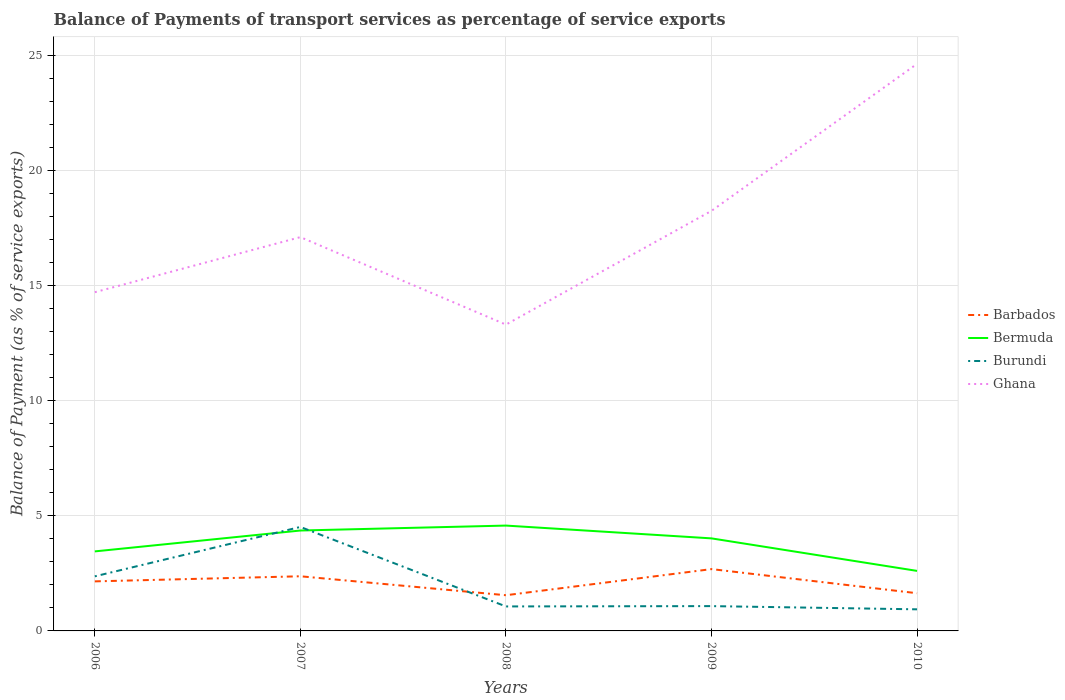Is the number of lines equal to the number of legend labels?
Your answer should be compact. Yes. Across all years, what is the maximum balance of payments of transport services in Ghana?
Provide a succinct answer. 13.3. In which year was the balance of payments of transport services in Bermuda maximum?
Offer a terse response. 2010. What is the total balance of payments of transport services in Burundi in the graph?
Your response must be concise. 0.14. What is the difference between the highest and the second highest balance of payments of transport services in Barbados?
Ensure brevity in your answer.  1.13. What is the difference between the highest and the lowest balance of payments of transport services in Barbados?
Give a very brief answer. 3. How many lines are there?
Offer a very short reply. 4. What is the difference between two consecutive major ticks on the Y-axis?
Your answer should be compact. 5. Are the values on the major ticks of Y-axis written in scientific E-notation?
Give a very brief answer. No. Does the graph contain any zero values?
Provide a succinct answer. No. Does the graph contain grids?
Provide a succinct answer. Yes. Where does the legend appear in the graph?
Offer a terse response. Center right. How many legend labels are there?
Offer a very short reply. 4. How are the legend labels stacked?
Ensure brevity in your answer.  Vertical. What is the title of the graph?
Your response must be concise. Balance of Payments of transport services as percentage of service exports. Does "Belgium" appear as one of the legend labels in the graph?
Give a very brief answer. No. What is the label or title of the X-axis?
Ensure brevity in your answer.  Years. What is the label or title of the Y-axis?
Provide a succinct answer. Balance of Payment (as % of service exports). What is the Balance of Payment (as % of service exports) of Barbados in 2006?
Your answer should be compact. 2.15. What is the Balance of Payment (as % of service exports) of Bermuda in 2006?
Give a very brief answer. 3.45. What is the Balance of Payment (as % of service exports) in Burundi in 2006?
Your answer should be very brief. 2.37. What is the Balance of Payment (as % of service exports) in Ghana in 2006?
Ensure brevity in your answer.  14.71. What is the Balance of Payment (as % of service exports) in Barbados in 2007?
Your response must be concise. 2.37. What is the Balance of Payment (as % of service exports) of Bermuda in 2007?
Provide a short and direct response. 4.36. What is the Balance of Payment (as % of service exports) of Burundi in 2007?
Give a very brief answer. 4.51. What is the Balance of Payment (as % of service exports) in Ghana in 2007?
Ensure brevity in your answer.  17.1. What is the Balance of Payment (as % of service exports) in Barbados in 2008?
Offer a very short reply. 1.55. What is the Balance of Payment (as % of service exports) in Bermuda in 2008?
Keep it short and to the point. 4.57. What is the Balance of Payment (as % of service exports) in Burundi in 2008?
Provide a succinct answer. 1.06. What is the Balance of Payment (as % of service exports) in Ghana in 2008?
Keep it short and to the point. 13.3. What is the Balance of Payment (as % of service exports) of Barbados in 2009?
Provide a short and direct response. 2.68. What is the Balance of Payment (as % of service exports) in Bermuda in 2009?
Your answer should be very brief. 4.02. What is the Balance of Payment (as % of service exports) in Burundi in 2009?
Ensure brevity in your answer.  1.08. What is the Balance of Payment (as % of service exports) in Ghana in 2009?
Ensure brevity in your answer.  18.24. What is the Balance of Payment (as % of service exports) in Barbados in 2010?
Your answer should be very brief. 1.64. What is the Balance of Payment (as % of service exports) of Bermuda in 2010?
Provide a succinct answer. 2.61. What is the Balance of Payment (as % of service exports) in Burundi in 2010?
Your response must be concise. 0.94. What is the Balance of Payment (as % of service exports) of Ghana in 2010?
Offer a very short reply. 24.62. Across all years, what is the maximum Balance of Payment (as % of service exports) in Barbados?
Your answer should be compact. 2.68. Across all years, what is the maximum Balance of Payment (as % of service exports) of Bermuda?
Make the answer very short. 4.57. Across all years, what is the maximum Balance of Payment (as % of service exports) of Burundi?
Provide a succinct answer. 4.51. Across all years, what is the maximum Balance of Payment (as % of service exports) of Ghana?
Give a very brief answer. 24.62. Across all years, what is the minimum Balance of Payment (as % of service exports) of Barbados?
Offer a terse response. 1.55. Across all years, what is the minimum Balance of Payment (as % of service exports) in Bermuda?
Provide a short and direct response. 2.61. Across all years, what is the minimum Balance of Payment (as % of service exports) of Burundi?
Your answer should be very brief. 0.94. Across all years, what is the minimum Balance of Payment (as % of service exports) of Ghana?
Make the answer very short. 13.3. What is the total Balance of Payment (as % of service exports) of Barbados in the graph?
Give a very brief answer. 10.4. What is the total Balance of Payment (as % of service exports) in Bermuda in the graph?
Offer a terse response. 19.01. What is the total Balance of Payment (as % of service exports) of Burundi in the graph?
Keep it short and to the point. 9.96. What is the total Balance of Payment (as % of service exports) of Ghana in the graph?
Offer a very short reply. 87.97. What is the difference between the Balance of Payment (as % of service exports) in Barbados in 2006 and that in 2007?
Ensure brevity in your answer.  -0.22. What is the difference between the Balance of Payment (as % of service exports) in Bermuda in 2006 and that in 2007?
Provide a succinct answer. -0.91. What is the difference between the Balance of Payment (as % of service exports) in Burundi in 2006 and that in 2007?
Offer a very short reply. -2.14. What is the difference between the Balance of Payment (as % of service exports) in Ghana in 2006 and that in 2007?
Provide a succinct answer. -2.39. What is the difference between the Balance of Payment (as % of service exports) in Barbados in 2006 and that in 2008?
Provide a succinct answer. 0.6. What is the difference between the Balance of Payment (as % of service exports) of Bermuda in 2006 and that in 2008?
Offer a very short reply. -1.12. What is the difference between the Balance of Payment (as % of service exports) in Burundi in 2006 and that in 2008?
Give a very brief answer. 1.31. What is the difference between the Balance of Payment (as % of service exports) in Ghana in 2006 and that in 2008?
Offer a very short reply. 1.41. What is the difference between the Balance of Payment (as % of service exports) in Barbados in 2006 and that in 2009?
Keep it short and to the point. -0.53. What is the difference between the Balance of Payment (as % of service exports) of Bermuda in 2006 and that in 2009?
Provide a short and direct response. -0.57. What is the difference between the Balance of Payment (as % of service exports) of Burundi in 2006 and that in 2009?
Give a very brief answer. 1.29. What is the difference between the Balance of Payment (as % of service exports) of Ghana in 2006 and that in 2009?
Keep it short and to the point. -3.53. What is the difference between the Balance of Payment (as % of service exports) of Barbados in 2006 and that in 2010?
Provide a succinct answer. 0.51. What is the difference between the Balance of Payment (as % of service exports) in Bermuda in 2006 and that in 2010?
Your response must be concise. 0.85. What is the difference between the Balance of Payment (as % of service exports) in Burundi in 2006 and that in 2010?
Ensure brevity in your answer.  1.43. What is the difference between the Balance of Payment (as % of service exports) of Ghana in 2006 and that in 2010?
Provide a short and direct response. -9.91. What is the difference between the Balance of Payment (as % of service exports) in Barbados in 2007 and that in 2008?
Ensure brevity in your answer.  0.82. What is the difference between the Balance of Payment (as % of service exports) in Bermuda in 2007 and that in 2008?
Your answer should be very brief. -0.21. What is the difference between the Balance of Payment (as % of service exports) in Burundi in 2007 and that in 2008?
Offer a terse response. 3.45. What is the difference between the Balance of Payment (as % of service exports) in Ghana in 2007 and that in 2008?
Offer a very short reply. 3.8. What is the difference between the Balance of Payment (as % of service exports) in Barbados in 2007 and that in 2009?
Ensure brevity in your answer.  -0.31. What is the difference between the Balance of Payment (as % of service exports) in Bermuda in 2007 and that in 2009?
Keep it short and to the point. 0.34. What is the difference between the Balance of Payment (as % of service exports) of Burundi in 2007 and that in 2009?
Provide a succinct answer. 3.44. What is the difference between the Balance of Payment (as % of service exports) of Ghana in 2007 and that in 2009?
Your answer should be very brief. -1.14. What is the difference between the Balance of Payment (as % of service exports) of Barbados in 2007 and that in 2010?
Provide a short and direct response. 0.74. What is the difference between the Balance of Payment (as % of service exports) of Bermuda in 2007 and that in 2010?
Offer a very short reply. 1.75. What is the difference between the Balance of Payment (as % of service exports) of Burundi in 2007 and that in 2010?
Your answer should be compact. 3.58. What is the difference between the Balance of Payment (as % of service exports) in Ghana in 2007 and that in 2010?
Your response must be concise. -7.52. What is the difference between the Balance of Payment (as % of service exports) in Barbados in 2008 and that in 2009?
Give a very brief answer. -1.13. What is the difference between the Balance of Payment (as % of service exports) of Bermuda in 2008 and that in 2009?
Your answer should be compact. 0.56. What is the difference between the Balance of Payment (as % of service exports) of Burundi in 2008 and that in 2009?
Your response must be concise. -0.01. What is the difference between the Balance of Payment (as % of service exports) of Ghana in 2008 and that in 2009?
Your answer should be compact. -4.94. What is the difference between the Balance of Payment (as % of service exports) of Barbados in 2008 and that in 2010?
Provide a short and direct response. -0.09. What is the difference between the Balance of Payment (as % of service exports) of Bermuda in 2008 and that in 2010?
Provide a short and direct response. 1.97. What is the difference between the Balance of Payment (as % of service exports) of Burundi in 2008 and that in 2010?
Provide a short and direct response. 0.13. What is the difference between the Balance of Payment (as % of service exports) in Ghana in 2008 and that in 2010?
Provide a succinct answer. -11.32. What is the difference between the Balance of Payment (as % of service exports) in Barbados in 2009 and that in 2010?
Your response must be concise. 1.05. What is the difference between the Balance of Payment (as % of service exports) of Bermuda in 2009 and that in 2010?
Your answer should be compact. 1.41. What is the difference between the Balance of Payment (as % of service exports) of Burundi in 2009 and that in 2010?
Keep it short and to the point. 0.14. What is the difference between the Balance of Payment (as % of service exports) in Ghana in 2009 and that in 2010?
Make the answer very short. -6.38. What is the difference between the Balance of Payment (as % of service exports) of Barbados in 2006 and the Balance of Payment (as % of service exports) of Bermuda in 2007?
Provide a succinct answer. -2.21. What is the difference between the Balance of Payment (as % of service exports) in Barbados in 2006 and the Balance of Payment (as % of service exports) in Burundi in 2007?
Ensure brevity in your answer.  -2.36. What is the difference between the Balance of Payment (as % of service exports) of Barbados in 2006 and the Balance of Payment (as % of service exports) of Ghana in 2007?
Your answer should be compact. -14.95. What is the difference between the Balance of Payment (as % of service exports) of Bermuda in 2006 and the Balance of Payment (as % of service exports) of Burundi in 2007?
Ensure brevity in your answer.  -1.06. What is the difference between the Balance of Payment (as % of service exports) in Bermuda in 2006 and the Balance of Payment (as % of service exports) in Ghana in 2007?
Your answer should be compact. -13.65. What is the difference between the Balance of Payment (as % of service exports) in Burundi in 2006 and the Balance of Payment (as % of service exports) in Ghana in 2007?
Offer a very short reply. -14.73. What is the difference between the Balance of Payment (as % of service exports) in Barbados in 2006 and the Balance of Payment (as % of service exports) in Bermuda in 2008?
Keep it short and to the point. -2.42. What is the difference between the Balance of Payment (as % of service exports) of Barbados in 2006 and the Balance of Payment (as % of service exports) of Burundi in 2008?
Offer a very short reply. 1.09. What is the difference between the Balance of Payment (as % of service exports) of Barbados in 2006 and the Balance of Payment (as % of service exports) of Ghana in 2008?
Provide a succinct answer. -11.15. What is the difference between the Balance of Payment (as % of service exports) in Bermuda in 2006 and the Balance of Payment (as % of service exports) in Burundi in 2008?
Ensure brevity in your answer.  2.39. What is the difference between the Balance of Payment (as % of service exports) in Bermuda in 2006 and the Balance of Payment (as % of service exports) in Ghana in 2008?
Your answer should be compact. -9.85. What is the difference between the Balance of Payment (as % of service exports) in Burundi in 2006 and the Balance of Payment (as % of service exports) in Ghana in 2008?
Make the answer very short. -10.93. What is the difference between the Balance of Payment (as % of service exports) in Barbados in 2006 and the Balance of Payment (as % of service exports) in Bermuda in 2009?
Offer a terse response. -1.87. What is the difference between the Balance of Payment (as % of service exports) in Barbados in 2006 and the Balance of Payment (as % of service exports) in Burundi in 2009?
Offer a terse response. 1.07. What is the difference between the Balance of Payment (as % of service exports) of Barbados in 2006 and the Balance of Payment (as % of service exports) of Ghana in 2009?
Your answer should be very brief. -16.09. What is the difference between the Balance of Payment (as % of service exports) of Bermuda in 2006 and the Balance of Payment (as % of service exports) of Burundi in 2009?
Provide a succinct answer. 2.38. What is the difference between the Balance of Payment (as % of service exports) in Bermuda in 2006 and the Balance of Payment (as % of service exports) in Ghana in 2009?
Give a very brief answer. -14.79. What is the difference between the Balance of Payment (as % of service exports) of Burundi in 2006 and the Balance of Payment (as % of service exports) of Ghana in 2009?
Give a very brief answer. -15.87. What is the difference between the Balance of Payment (as % of service exports) in Barbados in 2006 and the Balance of Payment (as % of service exports) in Bermuda in 2010?
Ensure brevity in your answer.  -0.45. What is the difference between the Balance of Payment (as % of service exports) in Barbados in 2006 and the Balance of Payment (as % of service exports) in Burundi in 2010?
Offer a terse response. 1.21. What is the difference between the Balance of Payment (as % of service exports) in Barbados in 2006 and the Balance of Payment (as % of service exports) in Ghana in 2010?
Provide a short and direct response. -22.47. What is the difference between the Balance of Payment (as % of service exports) in Bermuda in 2006 and the Balance of Payment (as % of service exports) in Burundi in 2010?
Provide a short and direct response. 2.52. What is the difference between the Balance of Payment (as % of service exports) of Bermuda in 2006 and the Balance of Payment (as % of service exports) of Ghana in 2010?
Provide a succinct answer. -21.17. What is the difference between the Balance of Payment (as % of service exports) in Burundi in 2006 and the Balance of Payment (as % of service exports) in Ghana in 2010?
Offer a very short reply. -22.25. What is the difference between the Balance of Payment (as % of service exports) of Barbados in 2007 and the Balance of Payment (as % of service exports) of Bermuda in 2008?
Your answer should be very brief. -2.2. What is the difference between the Balance of Payment (as % of service exports) in Barbados in 2007 and the Balance of Payment (as % of service exports) in Burundi in 2008?
Your answer should be very brief. 1.31. What is the difference between the Balance of Payment (as % of service exports) in Barbados in 2007 and the Balance of Payment (as % of service exports) in Ghana in 2008?
Ensure brevity in your answer.  -10.93. What is the difference between the Balance of Payment (as % of service exports) of Bermuda in 2007 and the Balance of Payment (as % of service exports) of Burundi in 2008?
Make the answer very short. 3.3. What is the difference between the Balance of Payment (as % of service exports) in Bermuda in 2007 and the Balance of Payment (as % of service exports) in Ghana in 2008?
Offer a terse response. -8.94. What is the difference between the Balance of Payment (as % of service exports) of Burundi in 2007 and the Balance of Payment (as % of service exports) of Ghana in 2008?
Your answer should be very brief. -8.79. What is the difference between the Balance of Payment (as % of service exports) in Barbados in 2007 and the Balance of Payment (as % of service exports) in Bermuda in 2009?
Provide a succinct answer. -1.65. What is the difference between the Balance of Payment (as % of service exports) of Barbados in 2007 and the Balance of Payment (as % of service exports) of Burundi in 2009?
Your answer should be compact. 1.3. What is the difference between the Balance of Payment (as % of service exports) in Barbados in 2007 and the Balance of Payment (as % of service exports) in Ghana in 2009?
Your response must be concise. -15.87. What is the difference between the Balance of Payment (as % of service exports) of Bermuda in 2007 and the Balance of Payment (as % of service exports) of Burundi in 2009?
Provide a succinct answer. 3.28. What is the difference between the Balance of Payment (as % of service exports) of Bermuda in 2007 and the Balance of Payment (as % of service exports) of Ghana in 2009?
Give a very brief answer. -13.88. What is the difference between the Balance of Payment (as % of service exports) in Burundi in 2007 and the Balance of Payment (as % of service exports) in Ghana in 2009?
Make the answer very short. -13.72. What is the difference between the Balance of Payment (as % of service exports) in Barbados in 2007 and the Balance of Payment (as % of service exports) in Bermuda in 2010?
Provide a short and direct response. -0.23. What is the difference between the Balance of Payment (as % of service exports) in Barbados in 2007 and the Balance of Payment (as % of service exports) in Burundi in 2010?
Your answer should be compact. 1.44. What is the difference between the Balance of Payment (as % of service exports) in Barbados in 2007 and the Balance of Payment (as % of service exports) in Ghana in 2010?
Your answer should be very brief. -22.25. What is the difference between the Balance of Payment (as % of service exports) of Bermuda in 2007 and the Balance of Payment (as % of service exports) of Burundi in 2010?
Your response must be concise. 3.42. What is the difference between the Balance of Payment (as % of service exports) in Bermuda in 2007 and the Balance of Payment (as % of service exports) in Ghana in 2010?
Provide a succinct answer. -20.26. What is the difference between the Balance of Payment (as % of service exports) of Burundi in 2007 and the Balance of Payment (as % of service exports) of Ghana in 2010?
Provide a succinct answer. -20.11. What is the difference between the Balance of Payment (as % of service exports) of Barbados in 2008 and the Balance of Payment (as % of service exports) of Bermuda in 2009?
Provide a short and direct response. -2.47. What is the difference between the Balance of Payment (as % of service exports) in Barbados in 2008 and the Balance of Payment (as % of service exports) in Burundi in 2009?
Provide a short and direct response. 0.47. What is the difference between the Balance of Payment (as % of service exports) in Barbados in 2008 and the Balance of Payment (as % of service exports) in Ghana in 2009?
Your answer should be compact. -16.69. What is the difference between the Balance of Payment (as % of service exports) of Bermuda in 2008 and the Balance of Payment (as % of service exports) of Burundi in 2009?
Your answer should be very brief. 3.5. What is the difference between the Balance of Payment (as % of service exports) of Bermuda in 2008 and the Balance of Payment (as % of service exports) of Ghana in 2009?
Provide a short and direct response. -13.66. What is the difference between the Balance of Payment (as % of service exports) of Burundi in 2008 and the Balance of Payment (as % of service exports) of Ghana in 2009?
Your answer should be compact. -17.18. What is the difference between the Balance of Payment (as % of service exports) in Barbados in 2008 and the Balance of Payment (as % of service exports) in Bermuda in 2010?
Offer a very short reply. -1.06. What is the difference between the Balance of Payment (as % of service exports) in Barbados in 2008 and the Balance of Payment (as % of service exports) in Burundi in 2010?
Ensure brevity in your answer.  0.61. What is the difference between the Balance of Payment (as % of service exports) of Barbados in 2008 and the Balance of Payment (as % of service exports) of Ghana in 2010?
Provide a succinct answer. -23.07. What is the difference between the Balance of Payment (as % of service exports) of Bermuda in 2008 and the Balance of Payment (as % of service exports) of Burundi in 2010?
Provide a succinct answer. 3.64. What is the difference between the Balance of Payment (as % of service exports) in Bermuda in 2008 and the Balance of Payment (as % of service exports) in Ghana in 2010?
Give a very brief answer. -20.05. What is the difference between the Balance of Payment (as % of service exports) in Burundi in 2008 and the Balance of Payment (as % of service exports) in Ghana in 2010?
Offer a terse response. -23.56. What is the difference between the Balance of Payment (as % of service exports) of Barbados in 2009 and the Balance of Payment (as % of service exports) of Bermuda in 2010?
Your answer should be compact. 0.08. What is the difference between the Balance of Payment (as % of service exports) of Barbados in 2009 and the Balance of Payment (as % of service exports) of Burundi in 2010?
Your response must be concise. 1.75. What is the difference between the Balance of Payment (as % of service exports) in Barbados in 2009 and the Balance of Payment (as % of service exports) in Ghana in 2010?
Your response must be concise. -21.94. What is the difference between the Balance of Payment (as % of service exports) in Bermuda in 2009 and the Balance of Payment (as % of service exports) in Burundi in 2010?
Make the answer very short. 3.08. What is the difference between the Balance of Payment (as % of service exports) of Bermuda in 2009 and the Balance of Payment (as % of service exports) of Ghana in 2010?
Offer a terse response. -20.6. What is the difference between the Balance of Payment (as % of service exports) of Burundi in 2009 and the Balance of Payment (as % of service exports) of Ghana in 2010?
Your answer should be compact. -23.54. What is the average Balance of Payment (as % of service exports) in Barbados per year?
Keep it short and to the point. 2.08. What is the average Balance of Payment (as % of service exports) in Bermuda per year?
Offer a very short reply. 3.8. What is the average Balance of Payment (as % of service exports) of Burundi per year?
Make the answer very short. 1.99. What is the average Balance of Payment (as % of service exports) of Ghana per year?
Offer a very short reply. 17.59. In the year 2006, what is the difference between the Balance of Payment (as % of service exports) in Barbados and Balance of Payment (as % of service exports) in Bermuda?
Your answer should be compact. -1.3. In the year 2006, what is the difference between the Balance of Payment (as % of service exports) in Barbados and Balance of Payment (as % of service exports) in Burundi?
Offer a terse response. -0.22. In the year 2006, what is the difference between the Balance of Payment (as % of service exports) of Barbados and Balance of Payment (as % of service exports) of Ghana?
Offer a very short reply. -12.56. In the year 2006, what is the difference between the Balance of Payment (as % of service exports) of Bermuda and Balance of Payment (as % of service exports) of Burundi?
Your response must be concise. 1.08. In the year 2006, what is the difference between the Balance of Payment (as % of service exports) of Bermuda and Balance of Payment (as % of service exports) of Ghana?
Your answer should be compact. -11.25. In the year 2006, what is the difference between the Balance of Payment (as % of service exports) of Burundi and Balance of Payment (as % of service exports) of Ghana?
Make the answer very short. -12.34. In the year 2007, what is the difference between the Balance of Payment (as % of service exports) in Barbados and Balance of Payment (as % of service exports) in Bermuda?
Provide a succinct answer. -1.99. In the year 2007, what is the difference between the Balance of Payment (as % of service exports) in Barbados and Balance of Payment (as % of service exports) in Burundi?
Give a very brief answer. -2.14. In the year 2007, what is the difference between the Balance of Payment (as % of service exports) in Barbados and Balance of Payment (as % of service exports) in Ghana?
Your answer should be compact. -14.73. In the year 2007, what is the difference between the Balance of Payment (as % of service exports) of Bermuda and Balance of Payment (as % of service exports) of Burundi?
Give a very brief answer. -0.16. In the year 2007, what is the difference between the Balance of Payment (as % of service exports) of Bermuda and Balance of Payment (as % of service exports) of Ghana?
Offer a very short reply. -12.74. In the year 2007, what is the difference between the Balance of Payment (as % of service exports) of Burundi and Balance of Payment (as % of service exports) of Ghana?
Your answer should be very brief. -12.58. In the year 2008, what is the difference between the Balance of Payment (as % of service exports) in Barbados and Balance of Payment (as % of service exports) in Bermuda?
Provide a short and direct response. -3.02. In the year 2008, what is the difference between the Balance of Payment (as % of service exports) of Barbados and Balance of Payment (as % of service exports) of Burundi?
Ensure brevity in your answer.  0.49. In the year 2008, what is the difference between the Balance of Payment (as % of service exports) of Barbados and Balance of Payment (as % of service exports) of Ghana?
Keep it short and to the point. -11.75. In the year 2008, what is the difference between the Balance of Payment (as % of service exports) of Bermuda and Balance of Payment (as % of service exports) of Burundi?
Provide a short and direct response. 3.51. In the year 2008, what is the difference between the Balance of Payment (as % of service exports) of Bermuda and Balance of Payment (as % of service exports) of Ghana?
Keep it short and to the point. -8.73. In the year 2008, what is the difference between the Balance of Payment (as % of service exports) of Burundi and Balance of Payment (as % of service exports) of Ghana?
Offer a terse response. -12.24. In the year 2009, what is the difference between the Balance of Payment (as % of service exports) of Barbados and Balance of Payment (as % of service exports) of Bermuda?
Your answer should be very brief. -1.33. In the year 2009, what is the difference between the Balance of Payment (as % of service exports) in Barbados and Balance of Payment (as % of service exports) in Burundi?
Provide a succinct answer. 1.61. In the year 2009, what is the difference between the Balance of Payment (as % of service exports) of Barbados and Balance of Payment (as % of service exports) of Ghana?
Ensure brevity in your answer.  -15.55. In the year 2009, what is the difference between the Balance of Payment (as % of service exports) in Bermuda and Balance of Payment (as % of service exports) in Burundi?
Your response must be concise. 2.94. In the year 2009, what is the difference between the Balance of Payment (as % of service exports) of Bermuda and Balance of Payment (as % of service exports) of Ghana?
Offer a very short reply. -14.22. In the year 2009, what is the difference between the Balance of Payment (as % of service exports) in Burundi and Balance of Payment (as % of service exports) in Ghana?
Your response must be concise. -17.16. In the year 2010, what is the difference between the Balance of Payment (as % of service exports) in Barbados and Balance of Payment (as % of service exports) in Bermuda?
Provide a short and direct response. -0.97. In the year 2010, what is the difference between the Balance of Payment (as % of service exports) in Barbados and Balance of Payment (as % of service exports) in Burundi?
Give a very brief answer. 0.7. In the year 2010, what is the difference between the Balance of Payment (as % of service exports) in Barbados and Balance of Payment (as % of service exports) in Ghana?
Provide a succinct answer. -22.98. In the year 2010, what is the difference between the Balance of Payment (as % of service exports) of Bermuda and Balance of Payment (as % of service exports) of Burundi?
Offer a terse response. 1.67. In the year 2010, what is the difference between the Balance of Payment (as % of service exports) in Bermuda and Balance of Payment (as % of service exports) in Ghana?
Keep it short and to the point. -22.02. In the year 2010, what is the difference between the Balance of Payment (as % of service exports) of Burundi and Balance of Payment (as % of service exports) of Ghana?
Ensure brevity in your answer.  -23.68. What is the ratio of the Balance of Payment (as % of service exports) in Barbados in 2006 to that in 2007?
Ensure brevity in your answer.  0.91. What is the ratio of the Balance of Payment (as % of service exports) of Bermuda in 2006 to that in 2007?
Your answer should be compact. 0.79. What is the ratio of the Balance of Payment (as % of service exports) in Burundi in 2006 to that in 2007?
Ensure brevity in your answer.  0.53. What is the ratio of the Balance of Payment (as % of service exports) in Ghana in 2006 to that in 2007?
Offer a very short reply. 0.86. What is the ratio of the Balance of Payment (as % of service exports) of Barbados in 2006 to that in 2008?
Provide a succinct answer. 1.39. What is the ratio of the Balance of Payment (as % of service exports) of Bermuda in 2006 to that in 2008?
Make the answer very short. 0.75. What is the ratio of the Balance of Payment (as % of service exports) in Burundi in 2006 to that in 2008?
Offer a terse response. 2.23. What is the ratio of the Balance of Payment (as % of service exports) in Ghana in 2006 to that in 2008?
Provide a succinct answer. 1.11. What is the ratio of the Balance of Payment (as % of service exports) of Barbados in 2006 to that in 2009?
Your answer should be compact. 0.8. What is the ratio of the Balance of Payment (as % of service exports) in Bermuda in 2006 to that in 2009?
Give a very brief answer. 0.86. What is the ratio of the Balance of Payment (as % of service exports) of Burundi in 2006 to that in 2009?
Your response must be concise. 2.2. What is the ratio of the Balance of Payment (as % of service exports) in Ghana in 2006 to that in 2009?
Provide a succinct answer. 0.81. What is the ratio of the Balance of Payment (as % of service exports) of Barbados in 2006 to that in 2010?
Offer a very short reply. 1.31. What is the ratio of the Balance of Payment (as % of service exports) of Bermuda in 2006 to that in 2010?
Provide a short and direct response. 1.32. What is the ratio of the Balance of Payment (as % of service exports) of Burundi in 2006 to that in 2010?
Offer a very short reply. 2.53. What is the ratio of the Balance of Payment (as % of service exports) in Ghana in 2006 to that in 2010?
Your answer should be very brief. 0.6. What is the ratio of the Balance of Payment (as % of service exports) of Barbados in 2007 to that in 2008?
Your answer should be very brief. 1.53. What is the ratio of the Balance of Payment (as % of service exports) of Bermuda in 2007 to that in 2008?
Offer a terse response. 0.95. What is the ratio of the Balance of Payment (as % of service exports) in Burundi in 2007 to that in 2008?
Offer a very short reply. 4.25. What is the ratio of the Balance of Payment (as % of service exports) in Ghana in 2007 to that in 2008?
Give a very brief answer. 1.29. What is the ratio of the Balance of Payment (as % of service exports) in Barbados in 2007 to that in 2009?
Keep it short and to the point. 0.88. What is the ratio of the Balance of Payment (as % of service exports) in Bermuda in 2007 to that in 2009?
Provide a short and direct response. 1.08. What is the ratio of the Balance of Payment (as % of service exports) in Burundi in 2007 to that in 2009?
Your answer should be very brief. 4.19. What is the ratio of the Balance of Payment (as % of service exports) of Ghana in 2007 to that in 2009?
Give a very brief answer. 0.94. What is the ratio of the Balance of Payment (as % of service exports) in Barbados in 2007 to that in 2010?
Your response must be concise. 1.45. What is the ratio of the Balance of Payment (as % of service exports) of Bermuda in 2007 to that in 2010?
Keep it short and to the point. 1.67. What is the ratio of the Balance of Payment (as % of service exports) in Burundi in 2007 to that in 2010?
Keep it short and to the point. 4.82. What is the ratio of the Balance of Payment (as % of service exports) in Ghana in 2007 to that in 2010?
Your answer should be compact. 0.69. What is the ratio of the Balance of Payment (as % of service exports) of Barbados in 2008 to that in 2009?
Your answer should be very brief. 0.58. What is the ratio of the Balance of Payment (as % of service exports) in Bermuda in 2008 to that in 2009?
Provide a short and direct response. 1.14. What is the ratio of the Balance of Payment (as % of service exports) of Burundi in 2008 to that in 2009?
Give a very brief answer. 0.99. What is the ratio of the Balance of Payment (as % of service exports) in Ghana in 2008 to that in 2009?
Your answer should be very brief. 0.73. What is the ratio of the Balance of Payment (as % of service exports) in Barbados in 2008 to that in 2010?
Give a very brief answer. 0.95. What is the ratio of the Balance of Payment (as % of service exports) of Bermuda in 2008 to that in 2010?
Ensure brevity in your answer.  1.75. What is the ratio of the Balance of Payment (as % of service exports) in Burundi in 2008 to that in 2010?
Offer a very short reply. 1.13. What is the ratio of the Balance of Payment (as % of service exports) in Ghana in 2008 to that in 2010?
Make the answer very short. 0.54. What is the ratio of the Balance of Payment (as % of service exports) in Barbados in 2009 to that in 2010?
Keep it short and to the point. 1.64. What is the ratio of the Balance of Payment (as % of service exports) of Bermuda in 2009 to that in 2010?
Ensure brevity in your answer.  1.54. What is the ratio of the Balance of Payment (as % of service exports) of Burundi in 2009 to that in 2010?
Provide a short and direct response. 1.15. What is the ratio of the Balance of Payment (as % of service exports) in Ghana in 2009 to that in 2010?
Make the answer very short. 0.74. What is the difference between the highest and the second highest Balance of Payment (as % of service exports) of Barbados?
Make the answer very short. 0.31. What is the difference between the highest and the second highest Balance of Payment (as % of service exports) in Bermuda?
Ensure brevity in your answer.  0.21. What is the difference between the highest and the second highest Balance of Payment (as % of service exports) of Burundi?
Provide a succinct answer. 2.14. What is the difference between the highest and the second highest Balance of Payment (as % of service exports) in Ghana?
Keep it short and to the point. 6.38. What is the difference between the highest and the lowest Balance of Payment (as % of service exports) of Barbados?
Offer a very short reply. 1.13. What is the difference between the highest and the lowest Balance of Payment (as % of service exports) in Bermuda?
Offer a terse response. 1.97. What is the difference between the highest and the lowest Balance of Payment (as % of service exports) in Burundi?
Provide a short and direct response. 3.58. What is the difference between the highest and the lowest Balance of Payment (as % of service exports) of Ghana?
Your response must be concise. 11.32. 